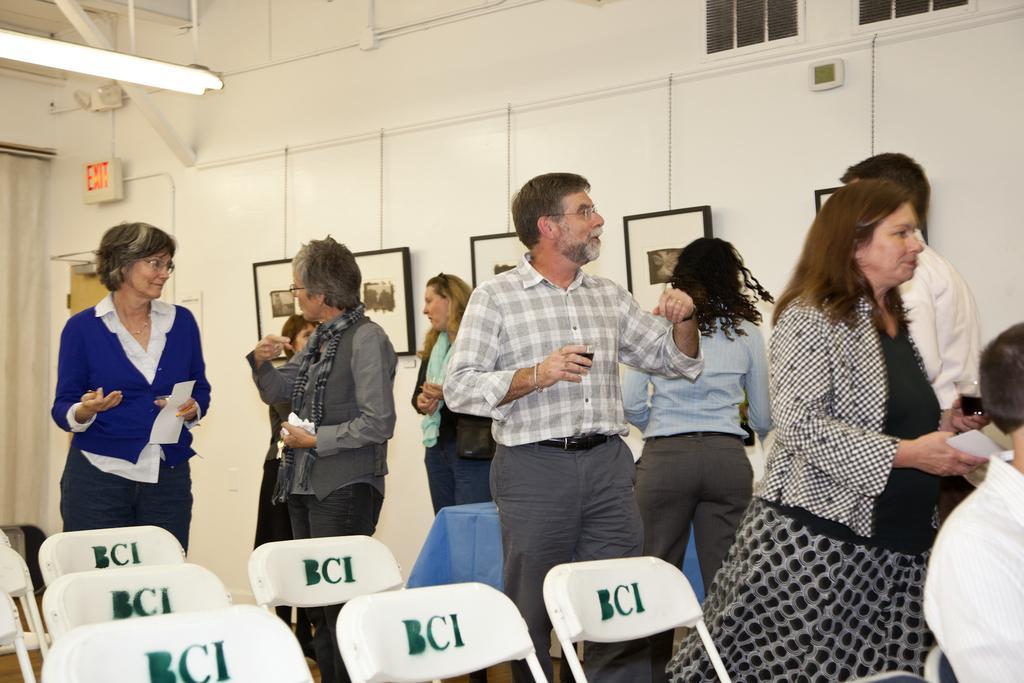Describe this image in one or two sentences. In this image there are chairs having some text on it. There are people standing on the floor. There are picture frames attached to the wall. Left top there is a light hanging from the roof. Right side a person is sitting on the chair. 